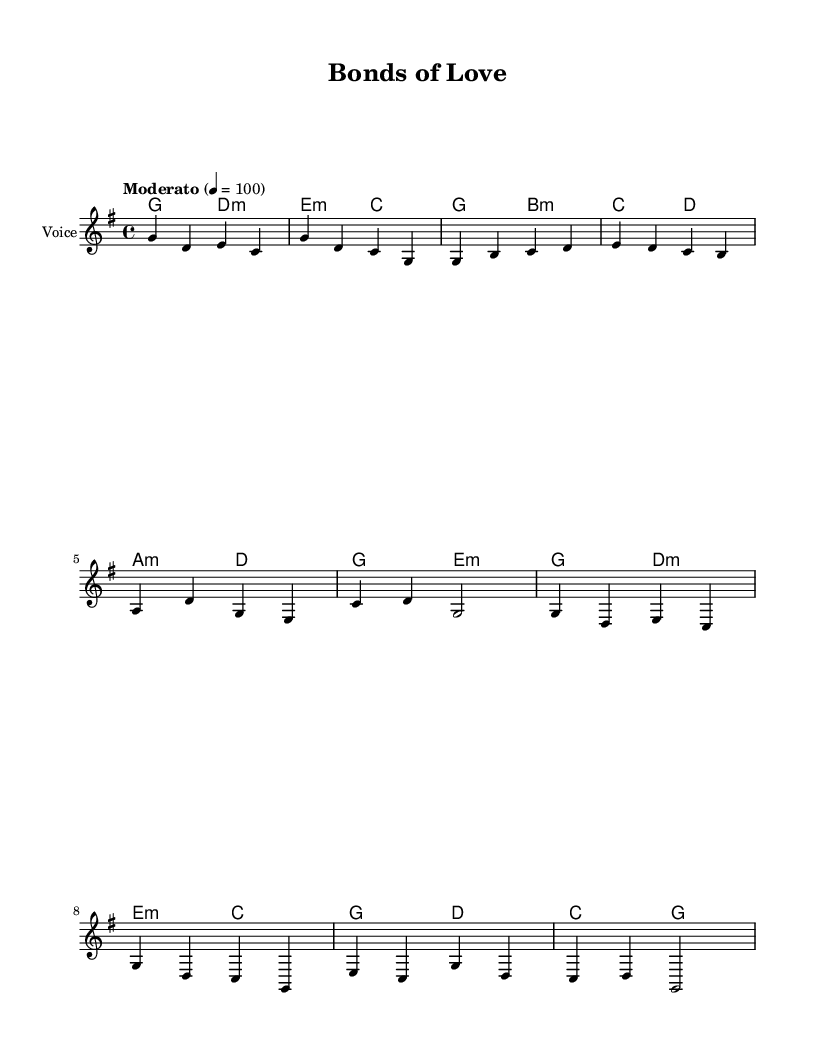What is the key signature of this music? The key signature indicates the tonal center of the piece, which is G major, as it has one sharp (F#) noted.
Answer: G major What is the time signature of this music? The time signature is found at the start of the music, expressed as 4/4, meaning there are 4 beats in each measure.
Answer: 4/4 What is the tempo marking of this music? The tempo marking is indicated in the score as "Moderato" at a speed of 100 beats per minute, guiding the performance speed.
Answer: Moderato How many measures are in the verse section? The verse consists of two phrases, with each phrase having four measures, totaling eight measures in the verse section.
Answer: 8 What is the main theme of the lyrics? The lyrics reflect unity and familial strength, focusing on the theme of support and love among families.
Answer: Love conquers all What is the harmony for the chorus section? The harmony for the chorus includes a sequence starting with G major, followed by D minor, E minor, and concluding with C major, which underpins the melody.
Answer: G, D minor, E minor, C How do the lyrics relate to world music themes? The lyrics emphasize community support and family ties, which are often central themes in world music traditions, promoting collective strength and harmony.
Answer: Community support 